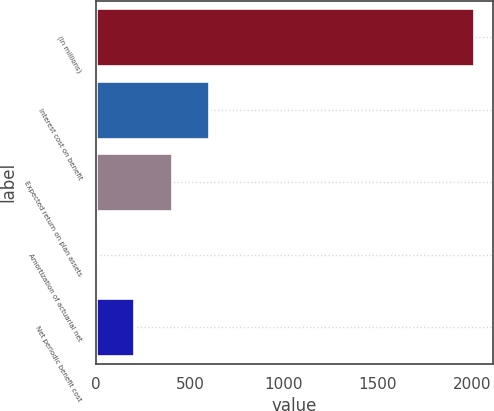Convert chart. <chart><loc_0><loc_0><loc_500><loc_500><bar_chart><fcel>(In millions)<fcel>Interest cost on benefit<fcel>Expected return on plan assets<fcel>Amortization of actuarial net<fcel>Net periodic benefit cost<nl><fcel>2010<fcel>603.91<fcel>403.04<fcel>1.3<fcel>202.17<nl></chart> 